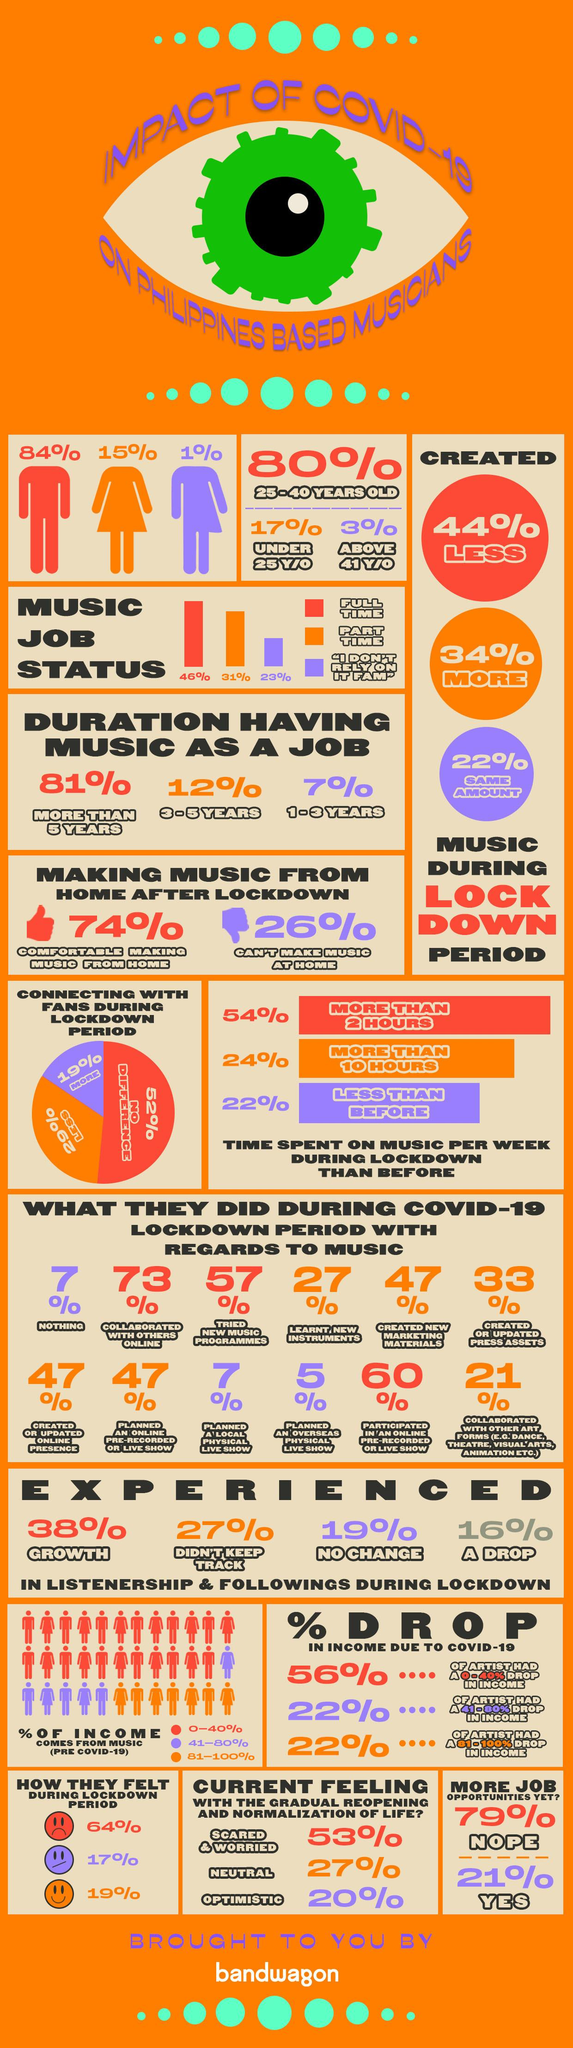Outline some significant characteristics in this image. During the lockdown period, 46% of Philippines-based musicians held full-time jobs while pursuing their musical careers. During the lockdown in the Philippines, 16% of musicians based in the country experienced a decline in listenership and followings. In the Philippines, a significant percentage of musicians who have been working in the music industry for more than 5 years is 81%. During the lockdown period, 31% of Philippines-based musicians held part-time jobs. During the lockdown period, a significant percentage of Philippines-based musicians created more music, with 34% of them crediting the isolation and forced creativity as a major source of inspiration for their music. 